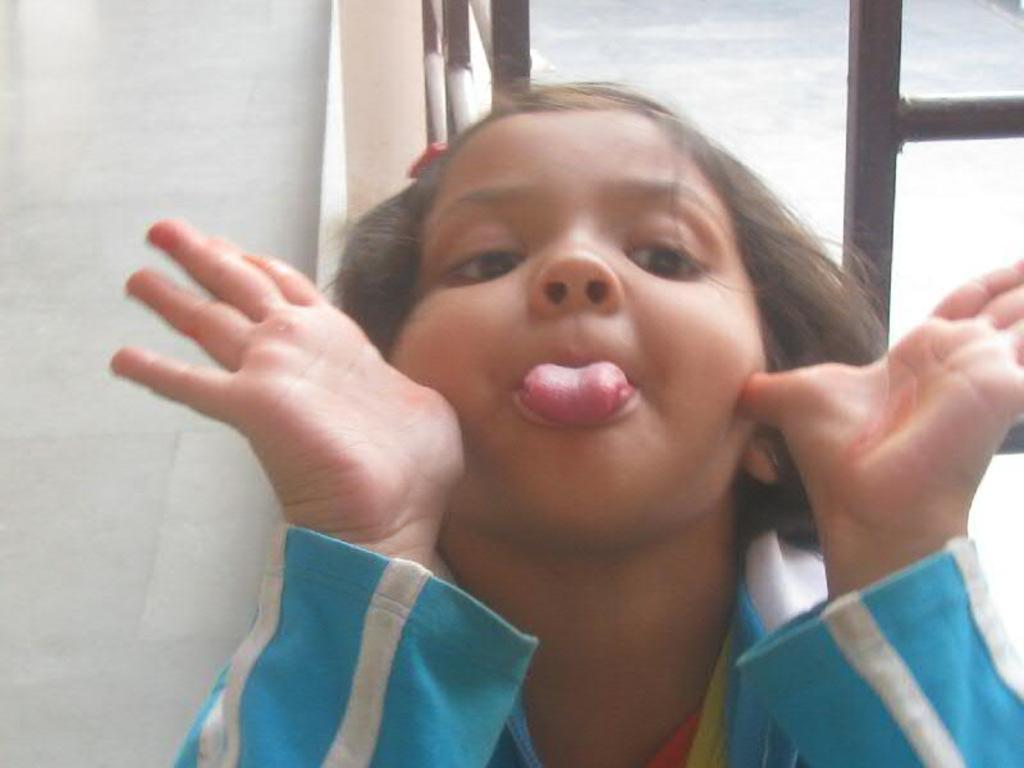Who is the main subject in the image? There is a girl in the center of the image. What can be seen in the background of the image? There is a window in the background of the image. What type of grape is the girl holding in the image? There is no grape present in the image; the girl is not holding any object. 